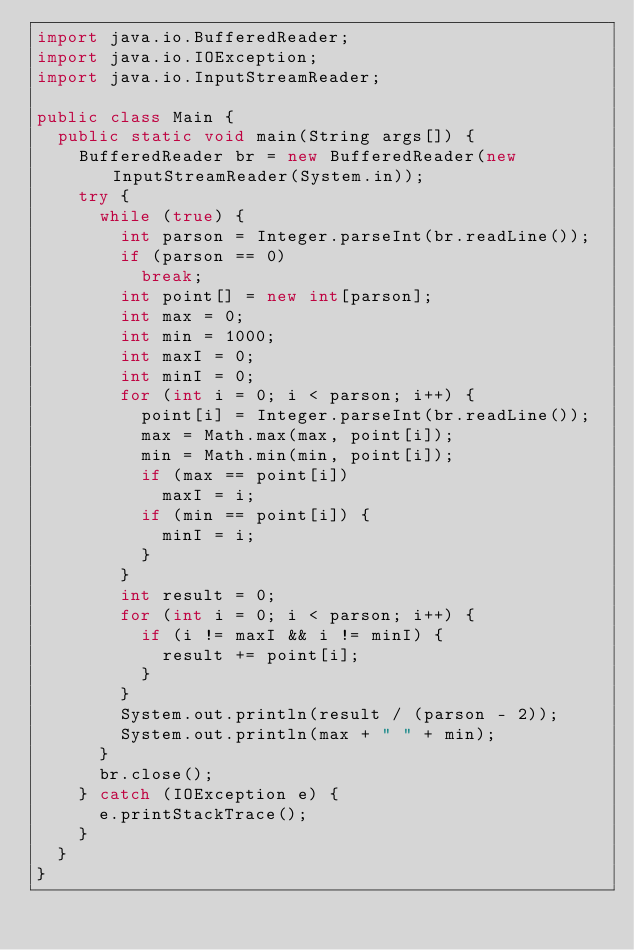Convert code to text. <code><loc_0><loc_0><loc_500><loc_500><_Java_>import java.io.BufferedReader;
import java.io.IOException;
import java.io.InputStreamReader;

public class Main {
	public static void main(String args[]) {
		BufferedReader br = new BufferedReader(new InputStreamReader(System.in));
		try {
			while (true) {
				int parson = Integer.parseInt(br.readLine());
				if (parson == 0)
					break;
				int point[] = new int[parson];
				int max = 0;
				int min = 1000;
				int maxI = 0;
				int minI = 0;
				for (int i = 0; i < parson; i++) {
					point[i] = Integer.parseInt(br.readLine());
					max = Math.max(max, point[i]);
					min = Math.min(min, point[i]);
					if (max == point[i])
						maxI = i;
					if (min == point[i]) {
						minI = i;
					}
				}
				int result = 0;
				for (int i = 0; i < parson; i++) {
					if (i != maxI && i != minI) {
						result += point[i];
					}
				}
				System.out.println(result / (parson - 2));
				System.out.println(max + " " + min);
			}
			br.close();
		} catch (IOException e) {
			e.printStackTrace();
		}
	}
}
</code> 